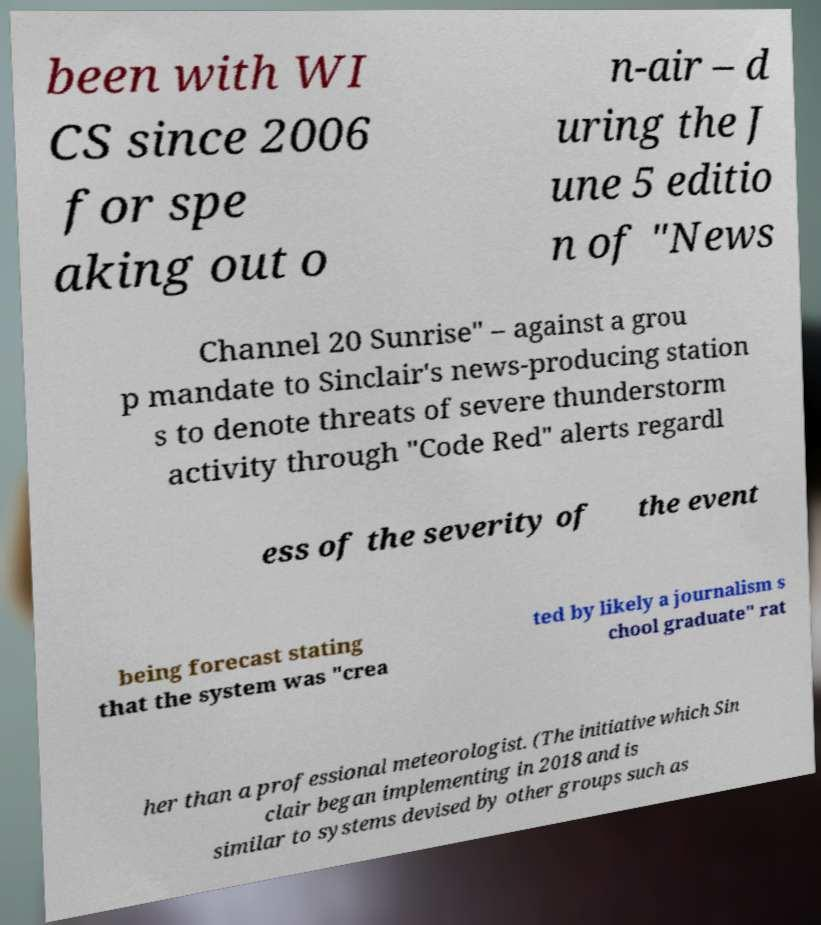Please read and relay the text visible in this image. What does it say? been with WI CS since 2006 for spe aking out o n-air – d uring the J une 5 editio n of "News Channel 20 Sunrise" – against a grou p mandate to Sinclair's news-producing station s to denote threats of severe thunderstorm activity through "Code Red" alerts regardl ess of the severity of the event being forecast stating that the system was "crea ted by likely a journalism s chool graduate" rat her than a professional meteorologist. (The initiative which Sin clair began implementing in 2018 and is similar to systems devised by other groups such as 